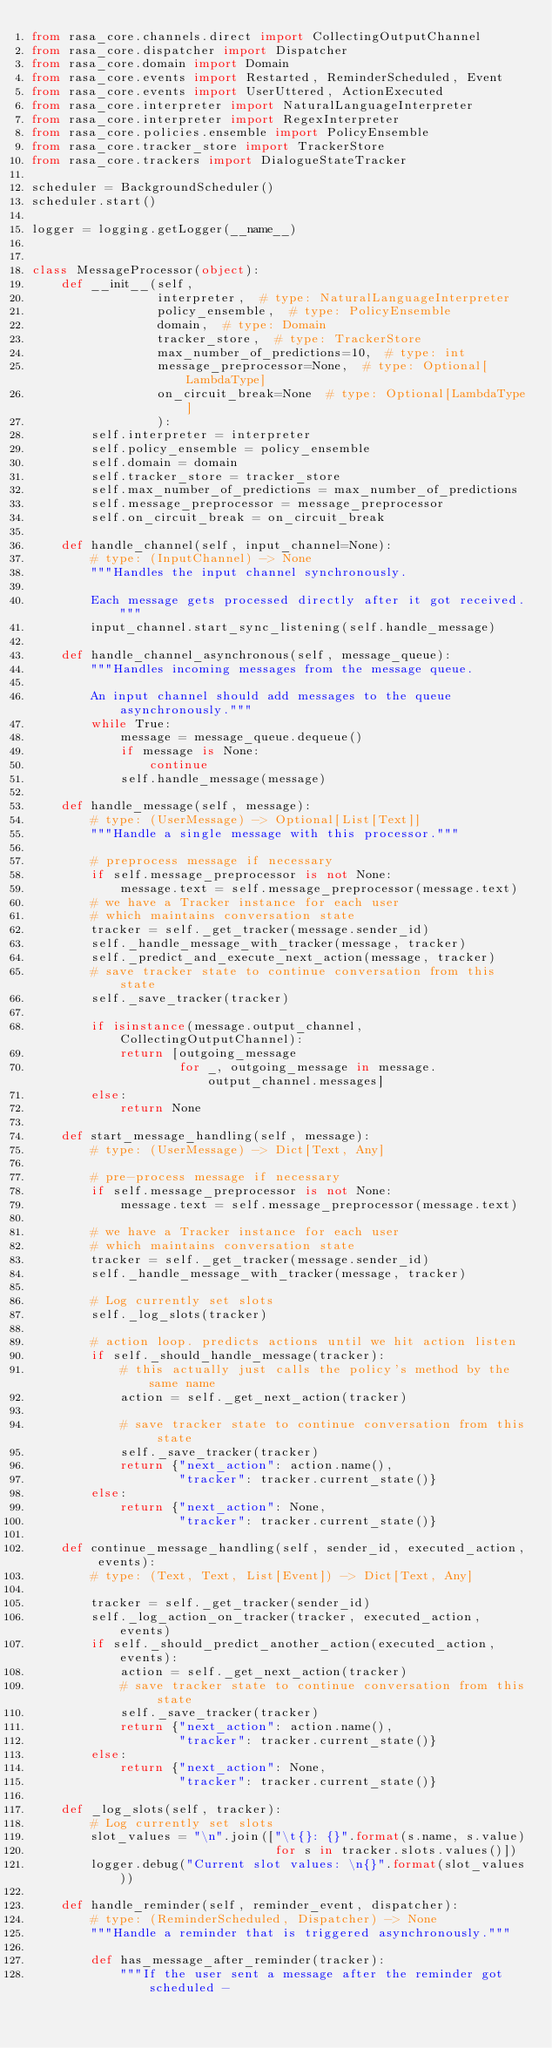Convert code to text. <code><loc_0><loc_0><loc_500><loc_500><_Python_>from rasa_core.channels.direct import CollectingOutputChannel
from rasa_core.dispatcher import Dispatcher
from rasa_core.domain import Domain
from rasa_core.events import Restarted, ReminderScheduled, Event
from rasa_core.events import UserUttered, ActionExecuted
from rasa_core.interpreter import NaturalLanguageInterpreter
from rasa_core.interpreter import RegexInterpreter
from rasa_core.policies.ensemble import PolicyEnsemble
from rasa_core.tracker_store import TrackerStore
from rasa_core.trackers import DialogueStateTracker

scheduler = BackgroundScheduler()
scheduler.start()

logger = logging.getLogger(__name__)


class MessageProcessor(object):
    def __init__(self,
                 interpreter,  # type: NaturalLanguageInterpreter
                 policy_ensemble,  # type: PolicyEnsemble
                 domain,  # type: Domain
                 tracker_store,  # type: TrackerStore
                 max_number_of_predictions=10,  # type: int
                 message_preprocessor=None,  # type: Optional[LambdaType]
                 on_circuit_break=None  # type: Optional[LambdaType]
                 ):
        self.interpreter = interpreter
        self.policy_ensemble = policy_ensemble
        self.domain = domain
        self.tracker_store = tracker_store
        self.max_number_of_predictions = max_number_of_predictions
        self.message_preprocessor = message_preprocessor
        self.on_circuit_break = on_circuit_break

    def handle_channel(self, input_channel=None):
        # type: (InputChannel) -> None
        """Handles the input channel synchronously.

        Each message gets processed directly after it got received."""
        input_channel.start_sync_listening(self.handle_message)

    def handle_channel_asynchronous(self, message_queue):
        """Handles incoming messages from the message queue.

        An input channel should add messages to the queue asynchronously."""
        while True:
            message = message_queue.dequeue()
            if message is None:
                continue
            self.handle_message(message)

    def handle_message(self, message):
        # type: (UserMessage) -> Optional[List[Text]]
        """Handle a single message with this processor."""

        # preprocess message if necessary
        if self.message_preprocessor is not None:
            message.text = self.message_preprocessor(message.text)
        # we have a Tracker instance for each user
        # which maintains conversation state
        tracker = self._get_tracker(message.sender_id)
        self._handle_message_with_tracker(message, tracker)
        self._predict_and_execute_next_action(message, tracker)
        # save tracker state to continue conversation from this state
        self._save_tracker(tracker)

        if isinstance(message.output_channel, CollectingOutputChannel):
            return [outgoing_message
                    for _, outgoing_message in message.output_channel.messages]
        else:
            return None

    def start_message_handling(self, message):
        # type: (UserMessage) -> Dict[Text, Any]

        # pre-process message if necessary
        if self.message_preprocessor is not None:
            message.text = self.message_preprocessor(message.text)

        # we have a Tracker instance for each user
        # which maintains conversation state
        tracker = self._get_tracker(message.sender_id)
        self._handle_message_with_tracker(message, tracker)

        # Log currently set slots
        self._log_slots(tracker)

        # action loop. predicts actions until we hit action listen
        if self._should_handle_message(tracker):
            # this actually just calls the policy's method by the same name
            action = self._get_next_action(tracker)

            # save tracker state to continue conversation from this state
            self._save_tracker(tracker)
            return {"next_action": action.name(),
                    "tracker": tracker.current_state()}
        else:
            return {"next_action": None,
                    "tracker": tracker.current_state()}

    def continue_message_handling(self, sender_id, executed_action, events):
        # type: (Text, Text, List[Event]) -> Dict[Text, Any]

        tracker = self._get_tracker(sender_id)
        self._log_action_on_tracker(tracker, executed_action, events)
        if self._should_predict_another_action(executed_action, events):
            action = self._get_next_action(tracker)
            # save tracker state to continue conversation from this state
            self._save_tracker(tracker)
            return {"next_action": action.name(),
                    "tracker": tracker.current_state()}
        else:
            return {"next_action": None,
                    "tracker": tracker.current_state()}

    def _log_slots(self, tracker):
        # Log currently set slots
        slot_values = "\n".join(["\t{}: {}".format(s.name, s.value)
                                 for s in tracker.slots.values()])
        logger.debug("Current slot values: \n{}".format(slot_values))

    def handle_reminder(self, reminder_event, dispatcher):
        # type: (ReminderScheduled, Dispatcher) -> None
        """Handle a reminder that is triggered asynchronously."""

        def has_message_after_reminder(tracker):
            """If the user sent a message after the reminder got scheduled -</code> 